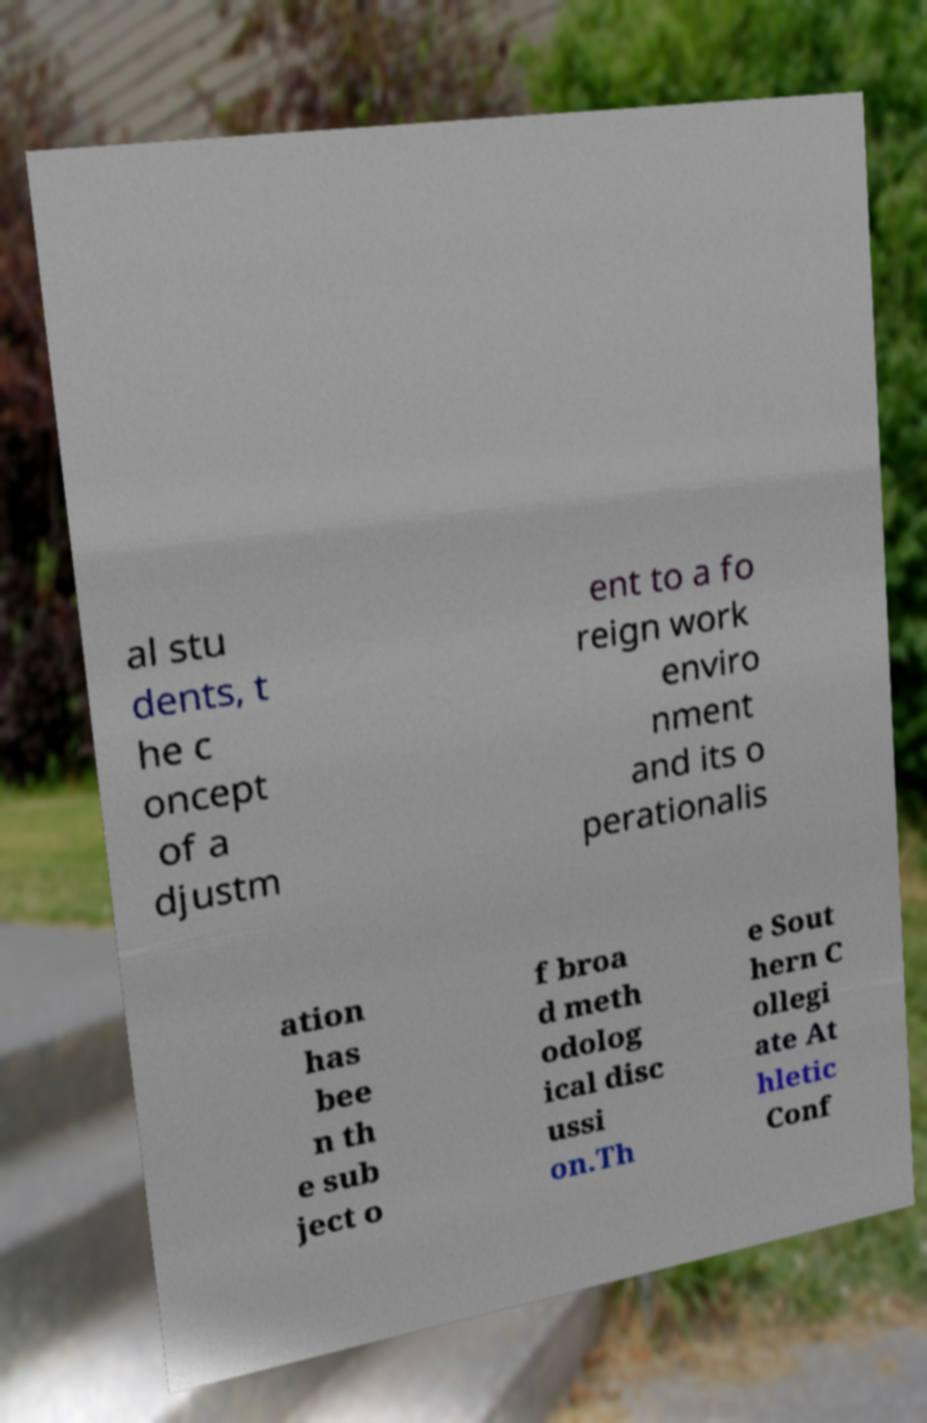Could you extract and type out the text from this image? al stu dents, t he c oncept of a djustm ent to a fo reign work enviro nment and its o perationalis ation has bee n th e sub ject o f broa d meth odolog ical disc ussi on.Th e Sout hern C ollegi ate At hletic Conf 